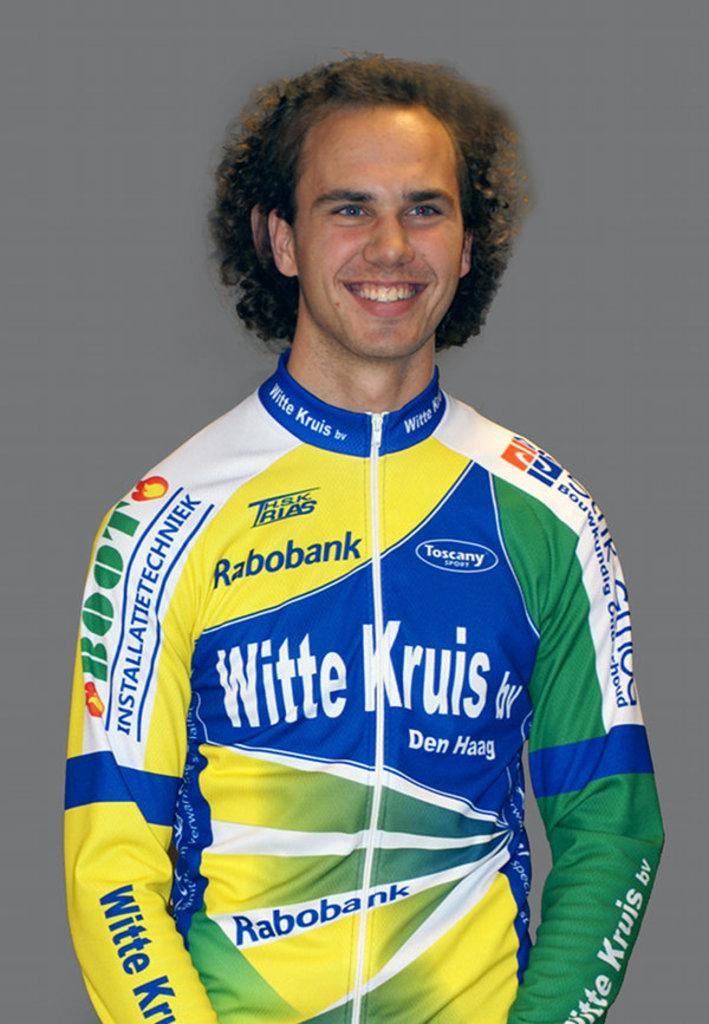<image>
Render a clear and concise summary of the photo. Man wearing a shirt which says "Witte Kruis" on it. 